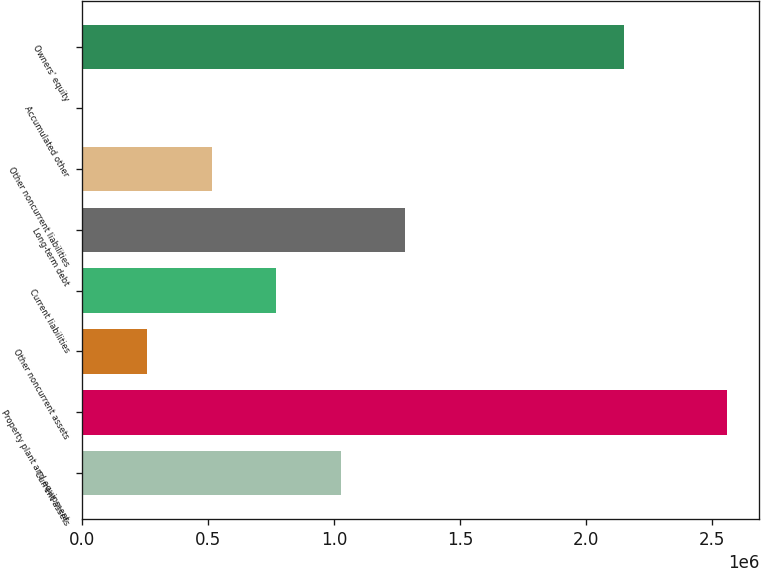Convert chart to OTSL. <chart><loc_0><loc_0><loc_500><loc_500><bar_chart><fcel>Current assets<fcel>Property plant and equipment<fcel>Other noncurrent assets<fcel>Current liabilities<fcel>Long-term debt<fcel>Other noncurrent liabilities<fcel>Accumulated other<fcel>Owners' equity<nl><fcel>1.0244e+06<fcel>2.55757e+06<fcel>257819<fcel>768875<fcel>1.27993e+06<fcel>513347<fcel>2291<fcel>2.15036e+06<nl></chart> 